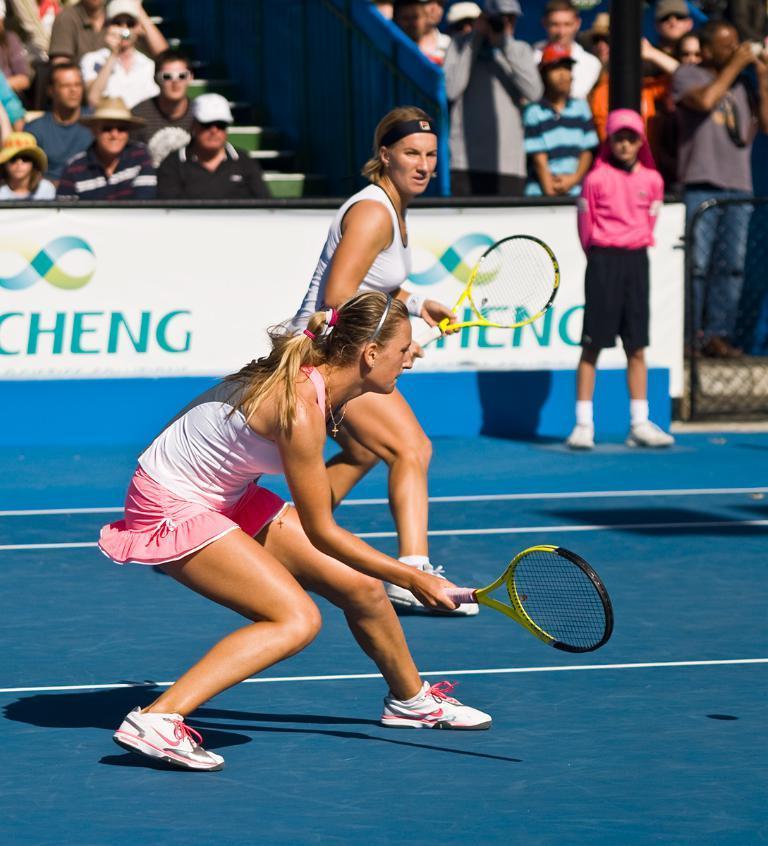Please provide a concise description of this image. In this image we can see a woman is standing and playing, and holding the racket in the hands, and at back here a group of persons are sitting, and some are standing. 